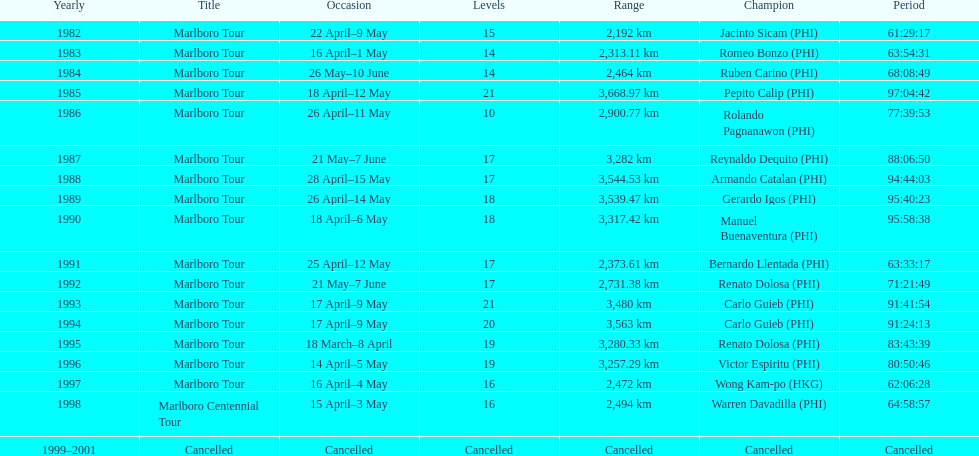Who is listed before wong kam-po? Victor Espiritu (PHI). 